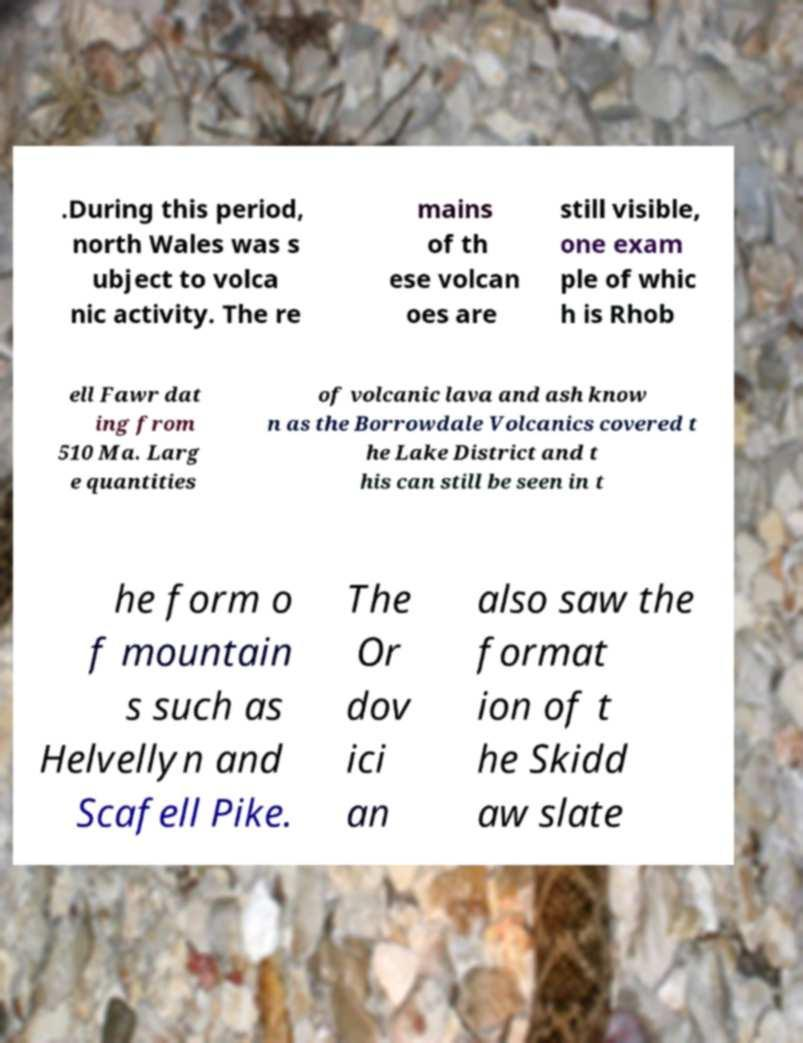Can you accurately transcribe the text from the provided image for me? .During this period, north Wales was s ubject to volca nic activity. The re mains of th ese volcan oes are still visible, one exam ple of whic h is Rhob ell Fawr dat ing from 510 Ma. Larg e quantities of volcanic lava and ash know n as the Borrowdale Volcanics covered t he Lake District and t his can still be seen in t he form o f mountain s such as Helvellyn and Scafell Pike. The Or dov ici an also saw the format ion of t he Skidd aw slate 